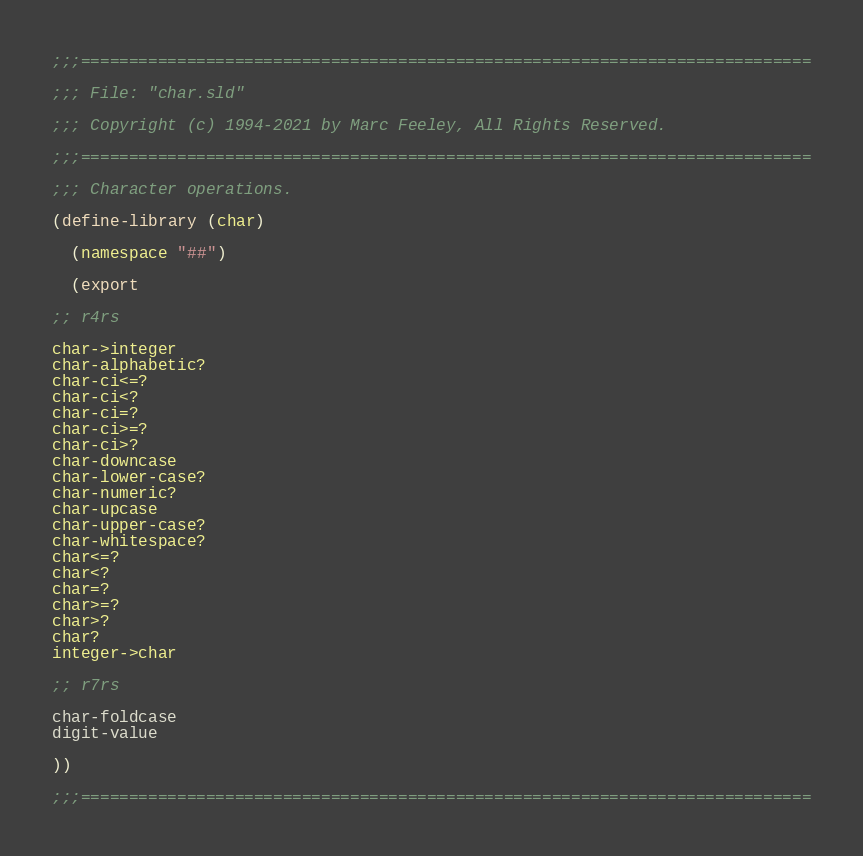<code> <loc_0><loc_0><loc_500><loc_500><_Scheme_>;;;============================================================================

;;; File: "char.sld"

;;; Copyright (c) 1994-2021 by Marc Feeley, All Rights Reserved.

;;;============================================================================

;;; Character operations.

(define-library (char)

  (namespace "##")

  (export

;; r4rs

char->integer
char-alphabetic?
char-ci<=?
char-ci<?
char-ci=?
char-ci>=?
char-ci>?
char-downcase
char-lower-case?
char-numeric?
char-upcase
char-upper-case?
char-whitespace?
char<=?
char<?
char=?
char>=?
char>?
char?
integer->char

;; r7rs

char-foldcase
digit-value

))

;;;============================================================================
</code> 